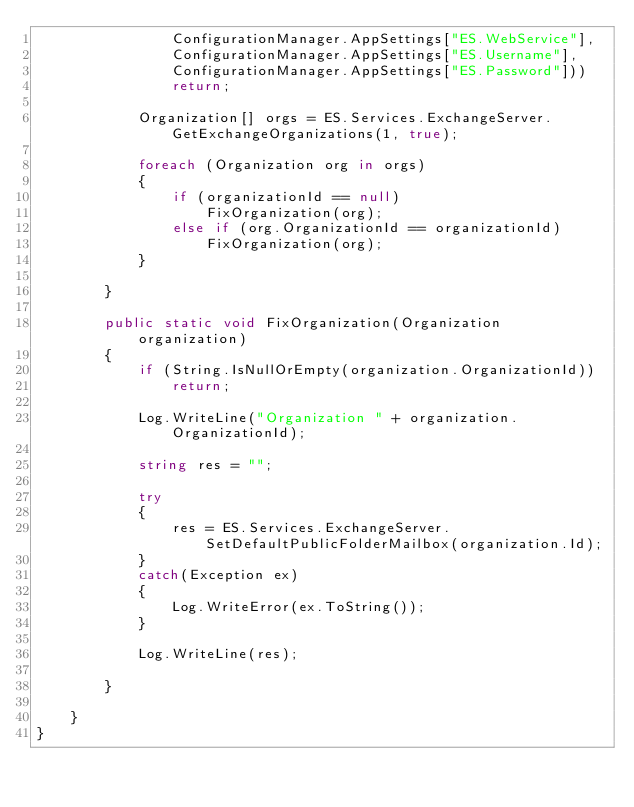Convert code to text. <code><loc_0><loc_0><loc_500><loc_500><_C#_>                ConfigurationManager.AppSettings["ES.WebService"],
                ConfigurationManager.AppSettings["ES.Username"],
                ConfigurationManager.AppSettings["ES.Password"]))
                return;

            Organization[] orgs = ES.Services.ExchangeServer.GetExchangeOrganizations(1, true);

            foreach (Organization org in orgs)
            {
                if (organizationId == null)
                    FixOrganization(org);
                else if (org.OrganizationId == organizationId)
                    FixOrganization(org);
            }

        }

        public static void FixOrganization(Organization organization)
        {
            if (String.IsNullOrEmpty(organization.OrganizationId))
                return;

            Log.WriteLine("Organization " + organization.OrganizationId);

            string res = "";

            try
            {
                res = ES.Services.ExchangeServer.SetDefaultPublicFolderMailbox(organization.Id);
            }
            catch(Exception ex)
            {
                Log.WriteError(ex.ToString());
            }

            Log.WriteLine(res);

        }

    }
}
</code> 